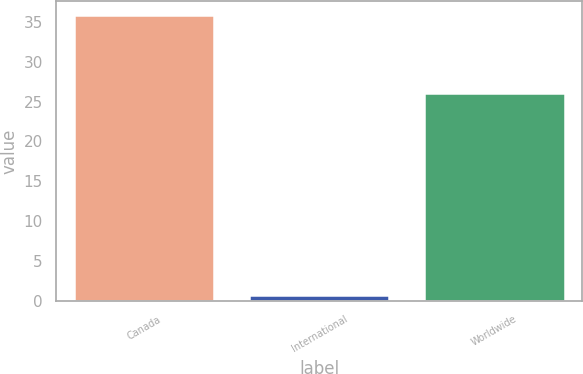<chart> <loc_0><loc_0><loc_500><loc_500><bar_chart><fcel>Canada<fcel>International<fcel>Worldwide<nl><fcel>35.8<fcel>0.8<fcel>26.1<nl></chart> 